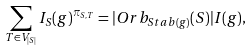<formula> <loc_0><loc_0><loc_500><loc_500>\sum _ { T \in V _ { | S | } } I _ { S } ( g ) ^ { \pi _ { S , T } } = | O r b _ { S t a b ( g ) } ( S ) | I ( g ) ,</formula> 